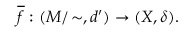<formula> <loc_0><loc_0><loc_500><loc_500>{ \overline { f } } \, \colon ( M / \, \sim , d ^ { \prime } ) \to ( X , \delta ) .</formula> 